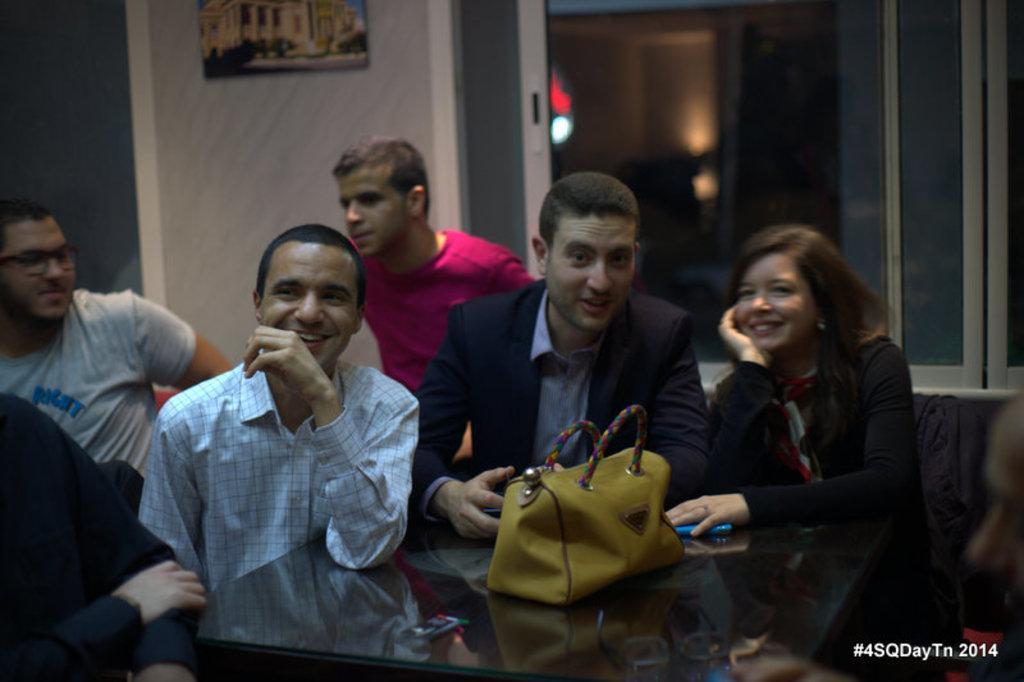Describe this image in one or two sentences. In this image, we can see a group of people are sitting. Here there is a table. On top of that there is a bag, people's hands and object. In the background, there is a wall, glass objects and photo frame. On the right side bottom corner, there is a watermark. 